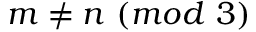Convert formula to latex. <formula><loc_0><loc_0><loc_500><loc_500>m \neq n \ ( m o d \ 3 )</formula> 